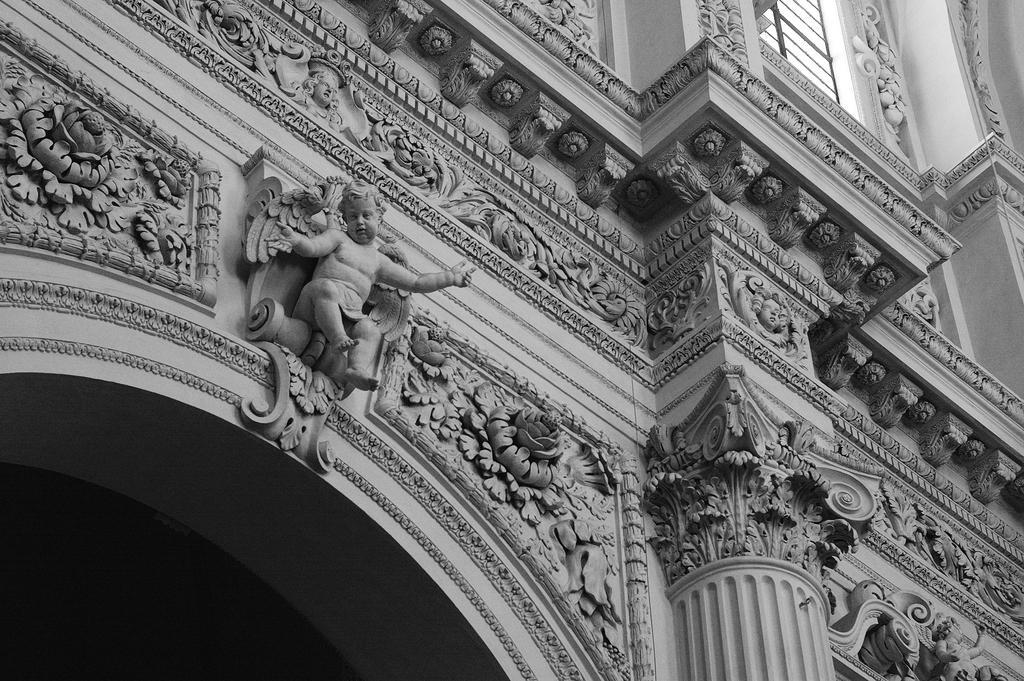Could you give a brief overview of what you see in this image? This image consists of a building. On which there is an art on the walls. In the front, there is a sculpture of a boy on the wall. 